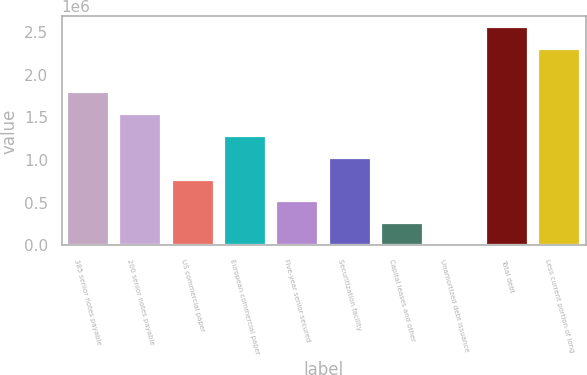Convert chart. <chart><loc_0><loc_0><loc_500><loc_500><bar_chart><fcel>385 senior notes payable<fcel>200 senior notes payable<fcel>US commercial paper<fcel>European commercial paper<fcel>Five-year senior secured<fcel>Securitization facility<fcel>Capital leases and other<fcel>Unamortized debt issuance<fcel>Total debt<fcel>Less current portion of long<nl><fcel>1.79201e+06<fcel>1.53703e+06<fcel>772072<fcel>1.28204e+06<fcel>517087<fcel>1.02706e+06<fcel>262102<fcel>7117<fcel>2.55697e+06<fcel>2.30198e+06<nl></chart> 